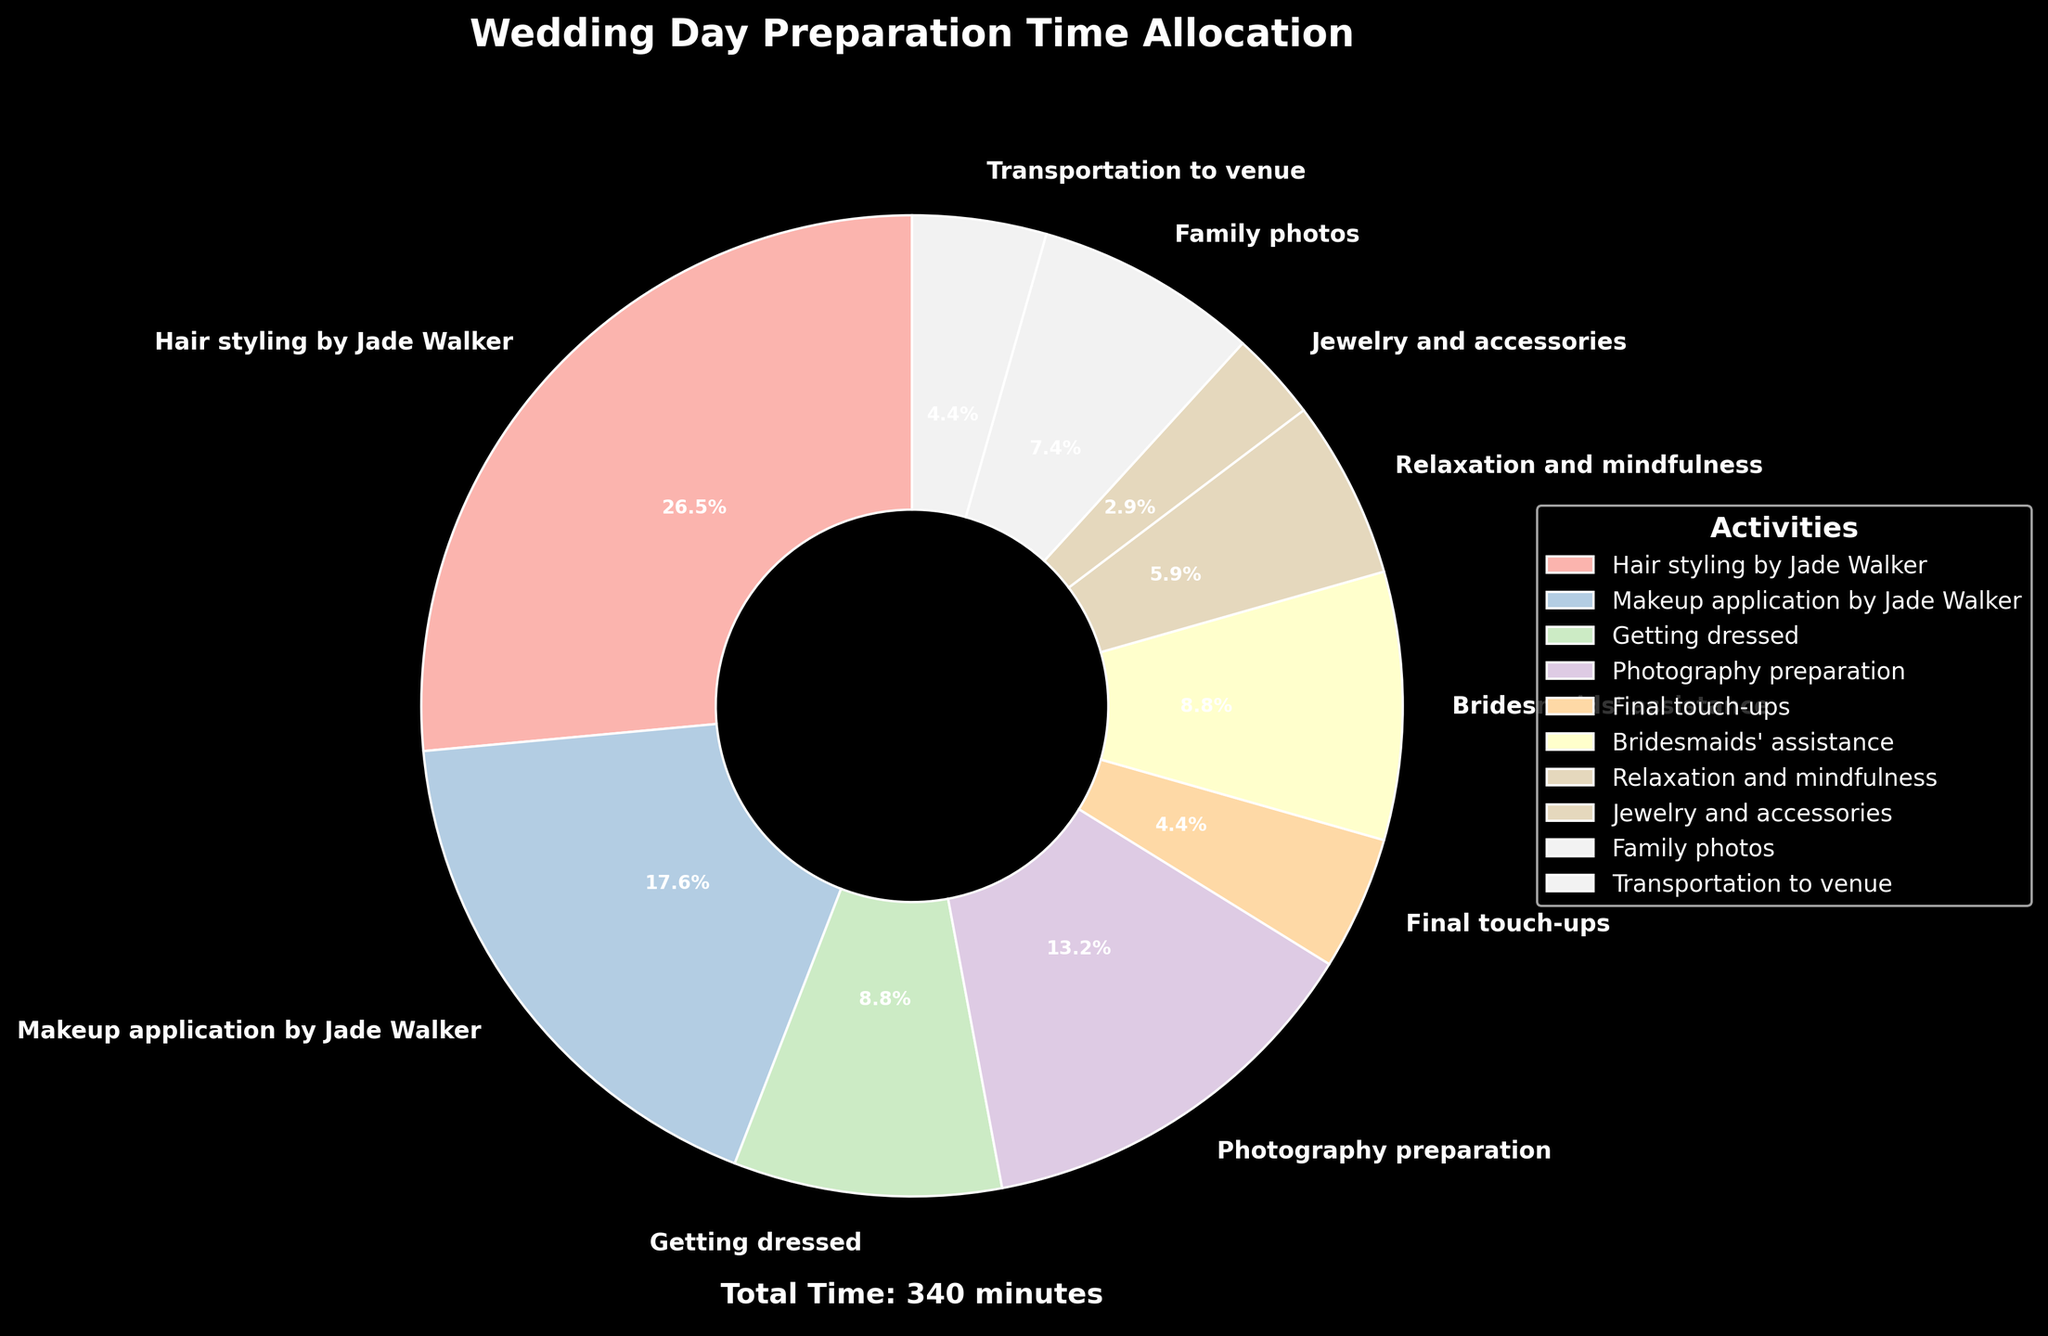Which activity takes the most time? The activity that takes the largest portion of the pie chart is "Hair styling by Jade Walker."
Answer: Hair styling by Jade Walker Which activity takes less time: Photography preparation or Family photos? Comparing the slices on the pie chart, "Photography preparation" takes 45 minutes while "Family photos" takes 25 minutes. Therefore, Family photos take less time.
Answer: Family photos What is the total time spent on activities done by Jade Walker? Both "Hair styling by Jade Walker" and "Makeup application by Jade Walker" are done by Jade Walker. Adding the time for these activities, 90 + 60 = 150 minutes.
Answer: 150 minutes How much time is spent on "Relaxation and mindfulness" compared to "Final touch-ups"? Looking at the pie chart, "Relaxation and mindfulness" takes 20 minutes and "Final touch-ups" takes 15 minutes. So, Relaxation and mindfulness takes 5 minutes more.
Answer: 5 minutes more What percentage of time is spent on Hair styling by Jade Walker? The slice for "Hair styling by Jade Walker" in the pie chart shows its percentage. The figure states it spends 90 minutes out of the total time (345 minutes). Calculating this percentage: (90 / 345) * 100 ≈ 26.1%.
Answer: 26.1% How much more time is spent on Getting dressed than on Jewelry and accessories? From the pie chart, "Getting dressed" takes 30 minutes and "Jewelry and accessories" takes 10 minutes. The difference is 30 - 10 = 20 minutes.
Answer: 20 minutes What's the average time spent on Bridesmaids' assistance, Final touch-ups, and Jewelry and accessories? Adding the times for these activities: 30 (Bridesmaids' assistance) + 15 (Final touch-ups) + 10 (Jewelry and accessories) = 55 minutes. There are 3 activities, so the average time is 55 / 3 ≈ 18.3 minutes.
Answer: 18.3 minutes Which activity takes more time: Transportation to venue or Final touch-ups? Comparing the slices on the pie chart, both "Transportation to venue" and "Final touch-ups" take 15 minutes each. Therefore, they take equal time.
Answer: They take equal time What is the sum of the times spent on activities not including Jade Walker? Adding the times for all activities except "Hair styling by Jade Walker" (90 minutes) and "Makeup application by Jade Walker" (60 minutes): 30 + 45 + 15 + 30 + 20 + 10 + 25 + 15 = 190 minutes.
Answer: 190 minutes How much less time is spent on Family photos than on Makeup application by Jade Walker? "Family photos" takes 25 minutes, while "Makeup application by Jade Walker" takes 60 minutes. The difference is 60 - 25 = 35 minutes.
Answer: 35 minutes 